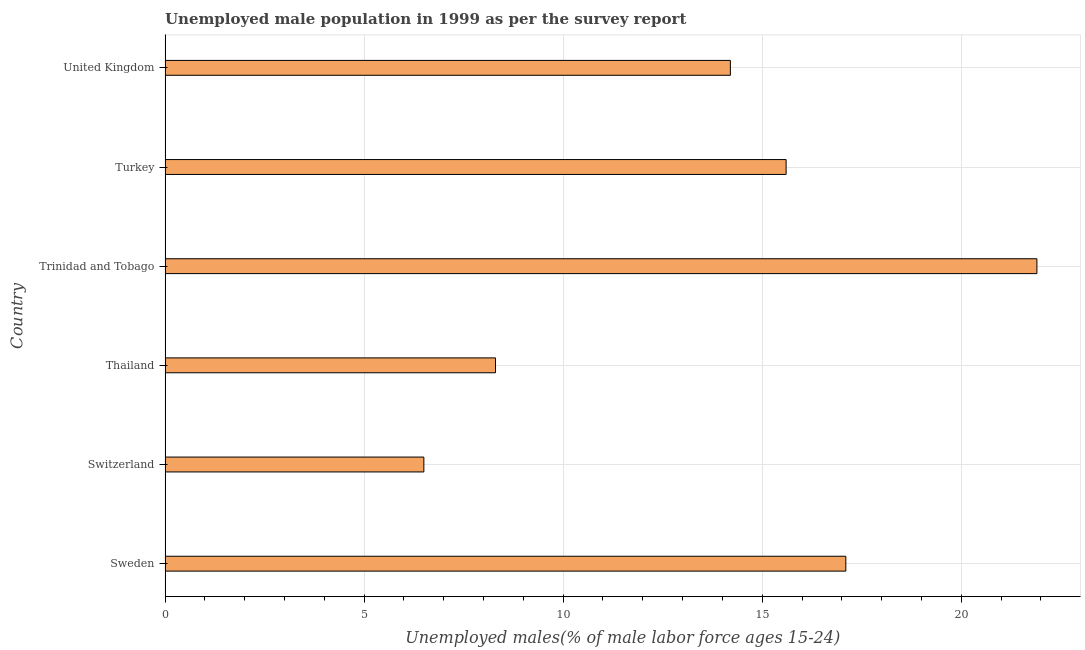What is the title of the graph?
Your response must be concise. Unemployed male population in 1999 as per the survey report. What is the label or title of the X-axis?
Provide a succinct answer. Unemployed males(% of male labor force ages 15-24). What is the label or title of the Y-axis?
Make the answer very short. Country. What is the unemployed male youth in Turkey?
Provide a short and direct response. 15.6. Across all countries, what is the maximum unemployed male youth?
Your answer should be compact. 21.9. In which country was the unemployed male youth maximum?
Keep it short and to the point. Trinidad and Tobago. In which country was the unemployed male youth minimum?
Your response must be concise. Switzerland. What is the sum of the unemployed male youth?
Offer a terse response. 83.6. What is the average unemployed male youth per country?
Give a very brief answer. 13.93. What is the median unemployed male youth?
Your answer should be very brief. 14.9. In how many countries, is the unemployed male youth greater than 6 %?
Give a very brief answer. 6. What is the ratio of the unemployed male youth in Switzerland to that in Thailand?
Provide a succinct answer. 0.78. Is the unemployed male youth in Switzerland less than that in United Kingdom?
Offer a very short reply. Yes. Is the sum of the unemployed male youth in Trinidad and Tobago and United Kingdom greater than the maximum unemployed male youth across all countries?
Your response must be concise. Yes. What is the difference between the highest and the lowest unemployed male youth?
Provide a succinct answer. 15.4. How many countries are there in the graph?
Provide a short and direct response. 6. What is the difference between two consecutive major ticks on the X-axis?
Keep it short and to the point. 5. What is the Unemployed males(% of male labor force ages 15-24) in Sweden?
Ensure brevity in your answer.  17.1. What is the Unemployed males(% of male labor force ages 15-24) of Thailand?
Ensure brevity in your answer.  8.3. What is the Unemployed males(% of male labor force ages 15-24) in Trinidad and Tobago?
Ensure brevity in your answer.  21.9. What is the Unemployed males(% of male labor force ages 15-24) of Turkey?
Offer a terse response. 15.6. What is the Unemployed males(% of male labor force ages 15-24) of United Kingdom?
Make the answer very short. 14.2. What is the difference between the Unemployed males(% of male labor force ages 15-24) in Sweden and Switzerland?
Keep it short and to the point. 10.6. What is the difference between the Unemployed males(% of male labor force ages 15-24) in Switzerland and Thailand?
Provide a succinct answer. -1.8. What is the difference between the Unemployed males(% of male labor force ages 15-24) in Switzerland and Trinidad and Tobago?
Your answer should be very brief. -15.4. What is the difference between the Unemployed males(% of male labor force ages 15-24) in Switzerland and United Kingdom?
Give a very brief answer. -7.7. What is the difference between the Unemployed males(% of male labor force ages 15-24) in Thailand and Turkey?
Give a very brief answer. -7.3. What is the difference between the Unemployed males(% of male labor force ages 15-24) in Thailand and United Kingdom?
Provide a short and direct response. -5.9. What is the difference between the Unemployed males(% of male labor force ages 15-24) in Trinidad and Tobago and United Kingdom?
Ensure brevity in your answer.  7.7. What is the ratio of the Unemployed males(% of male labor force ages 15-24) in Sweden to that in Switzerland?
Ensure brevity in your answer.  2.63. What is the ratio of the Unemployed males(% of male labor force ages 15-24) in Sweden to that in Thailand?
Offer a terse response. 2.06. What is the ratio of the Unemployed males(% of male labor force ages 15-24) in Sweden to that in Trinidad and Tobago?
Offer a very short reply. 0.78. What is the ratio of the Unemployed males(% of male labor force ages 15-24) in Sweden to that in Turkey?
Your answer should be very brief. 1.1. What is the ratio of the Unemployed males(% of male labor force ages 15-24) in Sweden to that in United Kingdom?
Ensure brevity in your answer.  1.2. What is the ratio of the Unemployed males(% of male labor force ages 15-24) in Switzerland to that in Thailand?
Give a very brief answer. 0.78. What is the ratio of the Unemployed males(% of male labor force ages 15-24) in Switzerland to that in Trinidad and Tobago?
Provide a short and direct response. 0.3. What is the ratio of the Unemployed males(% of male labor force ages 15-24) in Switzerland to that in Turkey?
Make the answer very short. 0.42. What is the ratio of the Unemployed males(% of male labor force ages 15-24) in Switzerland to that in United Kingdom?
Your answer should be compact. 0.46. What is the ratio of the Unemployed males(% of male labor force ages 15-24) in Thailand to that in Trinidad and Tobago?
Give a very brief answer. 0.38. What is the ratio of the Unemployed males(% of male labor force ages 15-24) in Thailand to that in Turkey?
Offer a very short reply. 0.53. What is the ratio of the Unemployed males(% of male labor force ages 15-24) in Thailand to that in United Kingdom?
Give a very brief answer. 0.58. What is the ratio of the Unemployed males(% of male labor force ages 15-24) in Trinidad and Tobago to that in Turkey?
Your answer should be compact. 1.4. What is the ratio of the Unemployed males(% of male labor force ages 15-24) in Trinidad and Tobago to that in United Kingdom?
Your answer should be very brief. 1.54. What is the ratio of the Unemployed males(% of male labor force ages 15-24) in Turkey to that in United Kingdom?
Make the answer very short. 1.1. 